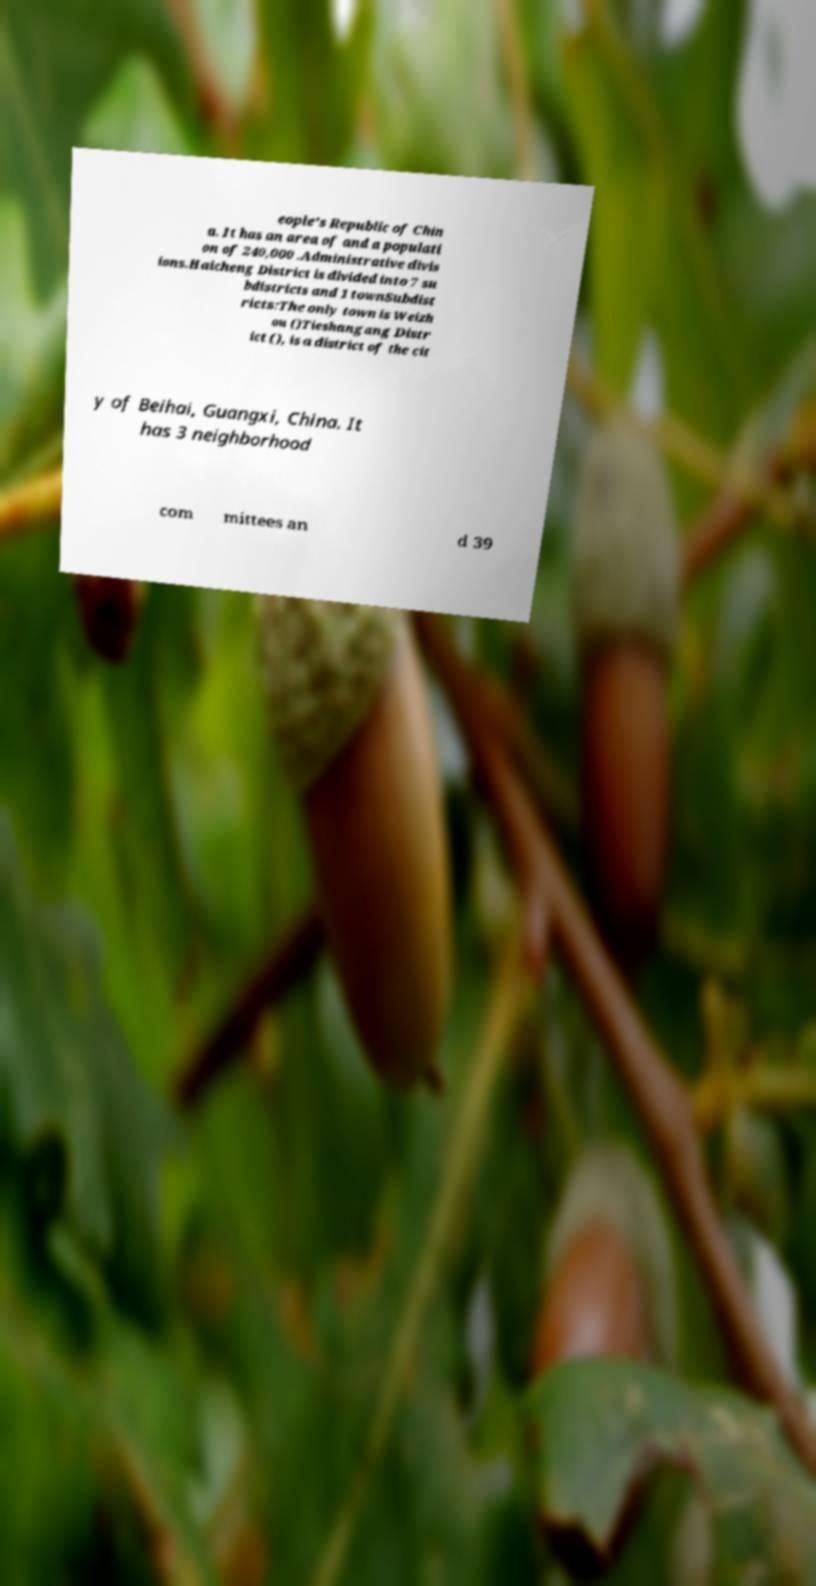There's text embedded in this image that I need extracted. Can you transcribe it verbatim? eople's Republic of Chin a. It has an area of and a populati on of 240,000 .Administrative divis ions.Haicheng District is divided into 7 su bdistricts and 1 townSubdist ricts:The only town is Weizh ou ()Tieshangang Distr ict (), is a district of the cit y of Beihai, Guangxi, China. It has 3 neighborhood com mittees an d 39 